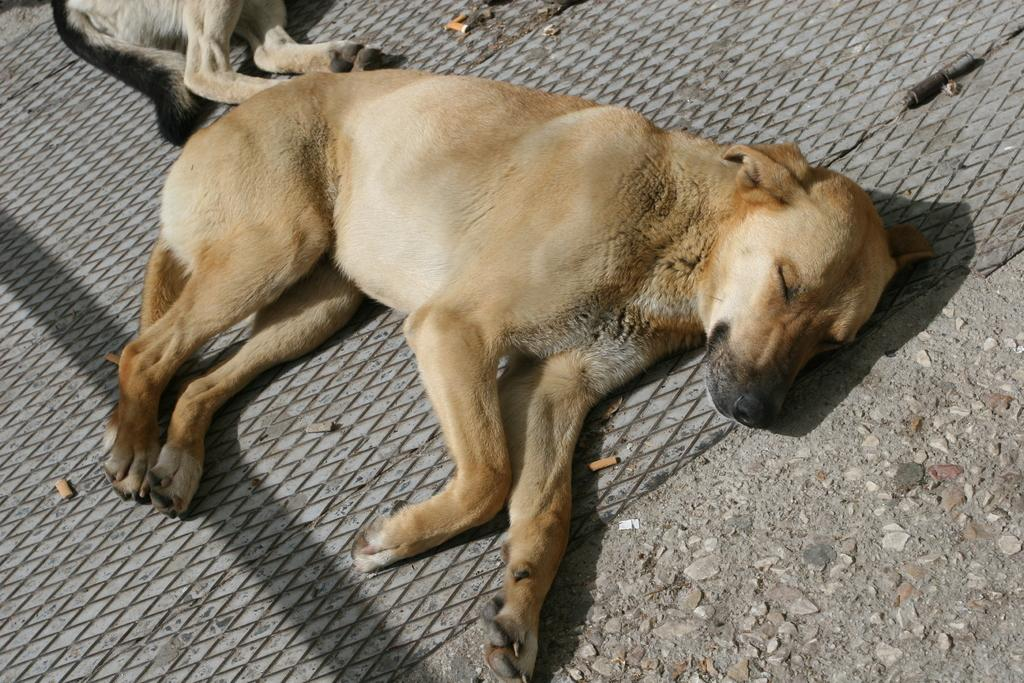What type of animal can be seen in the image? There is a dog in the image. What is the dog doing in the image? The dog is sleeping on a mat. Where is the mat located in the image? The mat is on the ground. Are there any other animals in the image? Yes, there is another dog in the image. What is the second dog doing in the image? The second dog is also sleeping on a mat. What color is the egg that the dog is holding in the image? There is no egg present in the image; the dog is sleeping on a mat. 